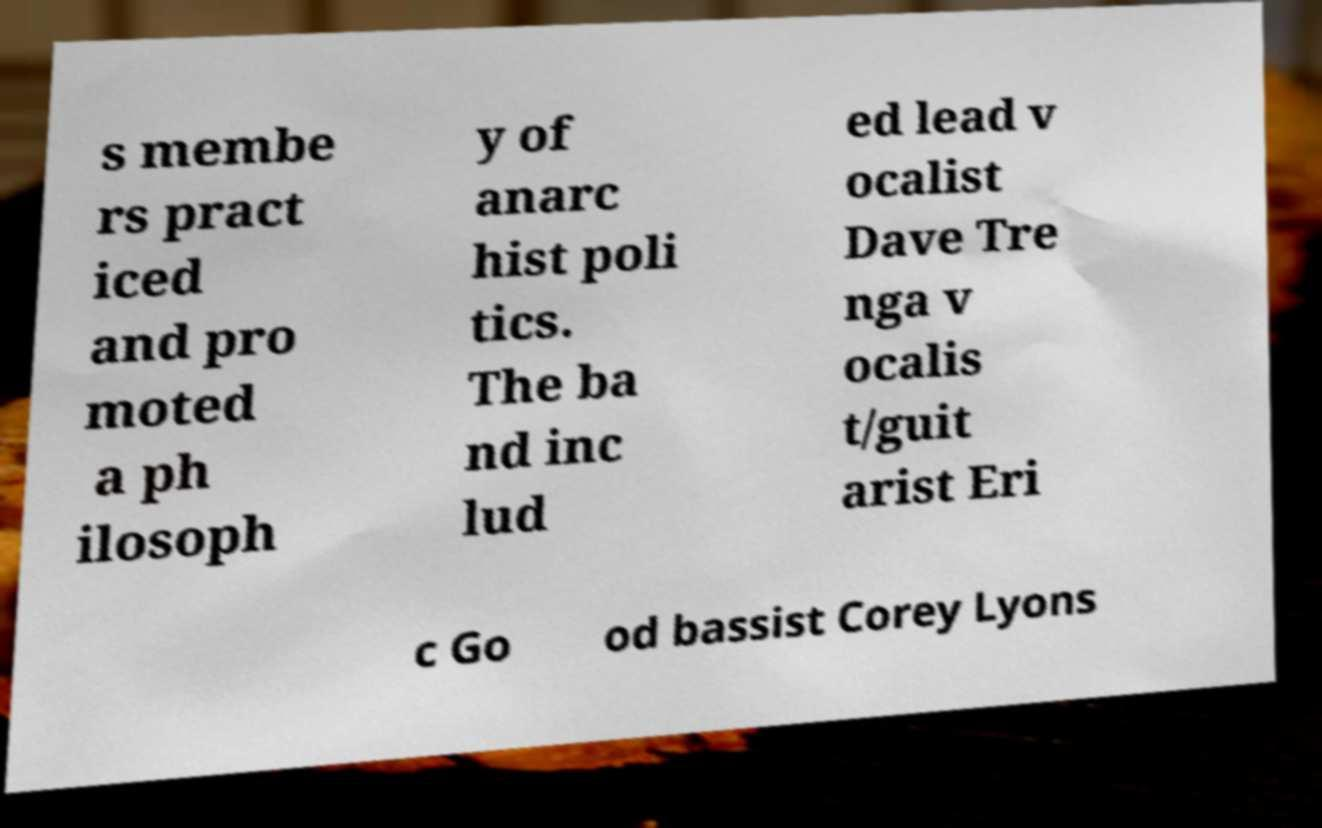I need the written content from this picture converted into text. Can you do that? s membe rs pract iced and pro moted a ph ilosoph y of anarc hist poli tics. The ba nd inc lud ed lead v ocalist Dave Tre nga v ocalis t/guit arist Eri c Go od bassist Corey Lyons 